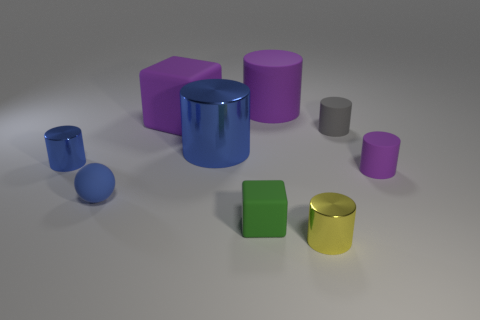What material is the tiny gray object that is the same shape as the yellow shiny object?
Your response must be concise. Rubber. Is there any other thing that has the same size as the green matte object?
Your answer should be very brief. Yes. The tiny thing that is in front of the tiny matte block has what shape?
Keep it short and to the point. Cylinder. What number of tiny yellow objects are the same shape as the tiny purple object?
Give a very brief answer. 1. Are there the same number of big blue metal cylinders that are to the right of the small purple rubber thing and blue things that are right of the large purple matte cylinder?
Offer a very short reply. Yes. Are there any large cyan objects made of the same material as the yellow thing?
Keep it short and to the point. No. Is the small yellow cylinder made of the same material as the tiny gray cylinder?
Your response must be concise. No. What number of blue objects are either matte cylinders or tiny things?
Make the answer very short. 2. Are there more large blue metallic things in front of the green cube than small purple rubber cylinders?
Provide a succinct answer. No. Are there any large shiny things that have the same color as the big cube?
Offer a terse response. No. 